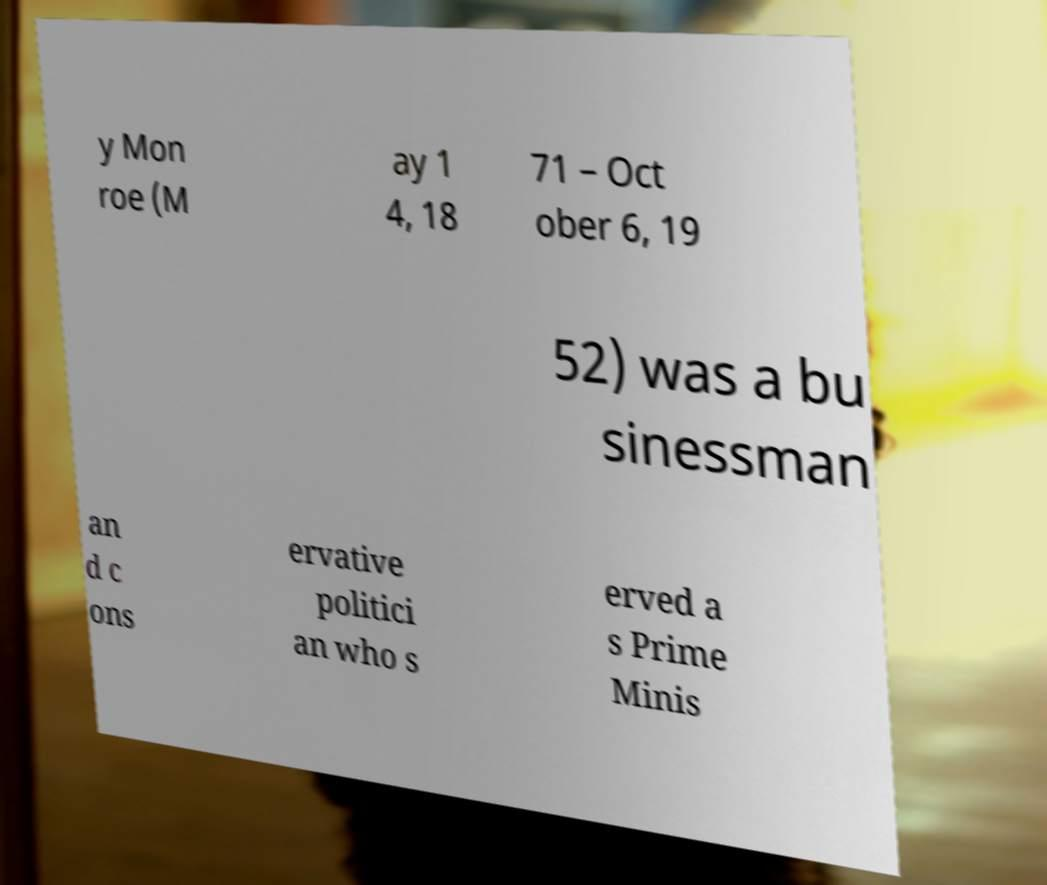Can you accurately transcribe the text from the provided image for me? y Mon roe (M ay 1 4, 18 71 – Oct ober 6, 19 52) was a bu sinessman an d c ons ervative politici an who s erved a s Prime Minis 